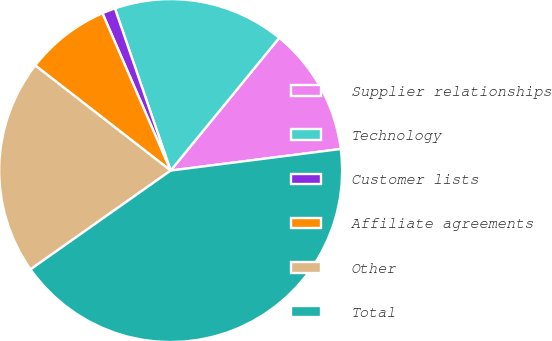Convert chart to OTSL. <chart><loc_0><loc_0><loc_500><loc_500><pie_chart><fcel>Supplier relationships<fcel>Technology<fcel>Customer lists<fcel>Affiliate agreements<fcel>Other<fcel>Total<nl><fcel>12.08%<fcel>16.18%<fcel>1.24%<fcel>7.98%<fcel>20.28%<fcel>42.23%<nl></chart> 